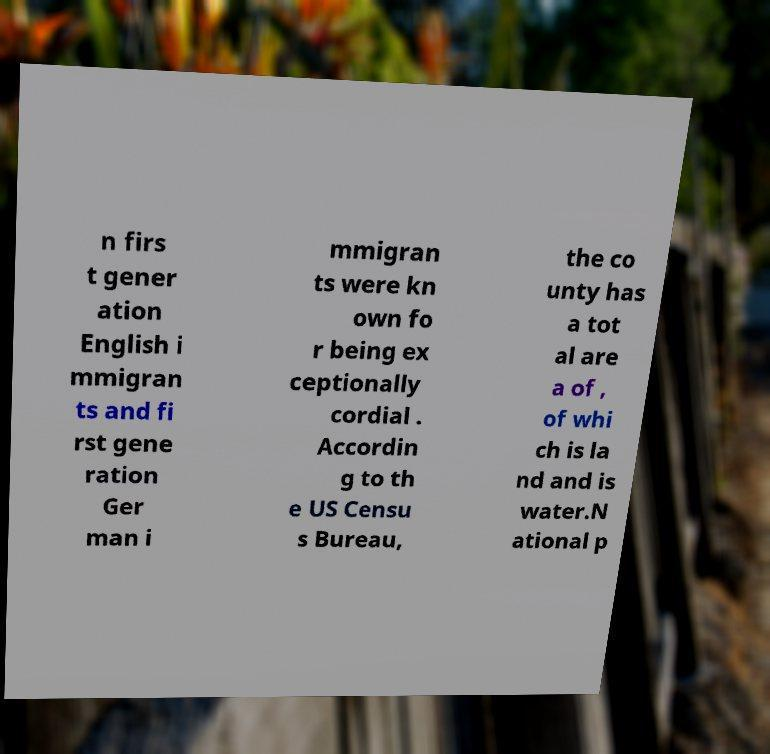Please read and relay the text visible in this image. What does it say? n firs t gener ation English i mmigran ts and fi rst gene ration Ger man i mmigran ts were kn own fo r being ex ceptionally cordial . Accordin g to th e US Censu s Bureau, the co unty has a tot al are a of , of whi ch is la nd and is water.N ational p 